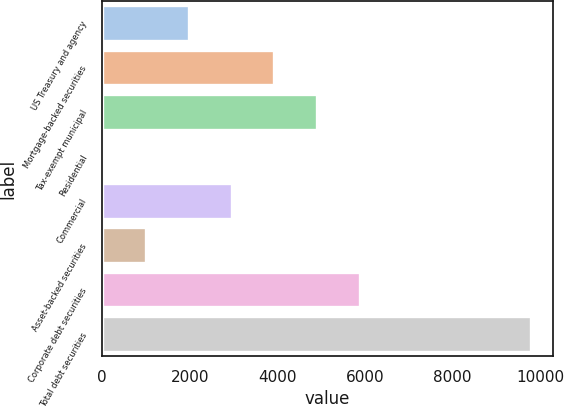Convert chart. <chart><loc_0><loc_0><loc_500><loc_500><bar_chart><fcel>US Treasury and agency<fcel>Mortgage-backed securities<fcel>Tax-exempt municipal<fcel>Residential<fcel>Commercial<fcel>Asset-backed securities<fcel>Corporate debt securities<fcel>Total debt securities<nl><fcel>1977.6<fcel>3933.2<fcel>4911<fcel>22<fcel>2955.4<fcel>999.8<fcel>5888.8<fcel>9800<nl></chart> 